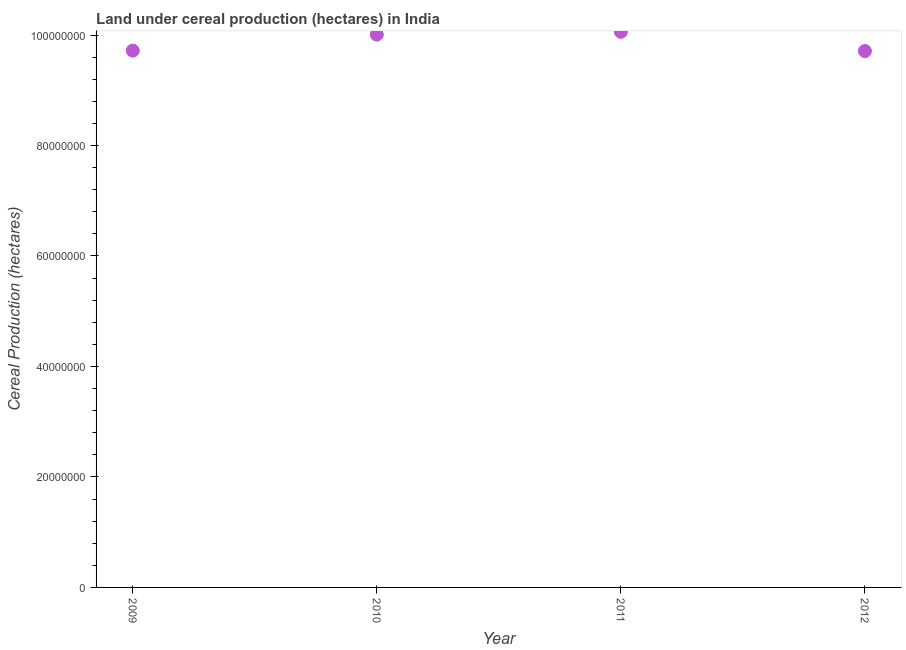What is the land under cereal production in 2011?
Provide a short and direct response. 1.01e+08. Across all years, what is the maximum land under cereal production?
Offer a terse response. 1.01e+08. Across all years, what is the minimum land under cereal production?
Offer a very short reply. 9.71e+07. What is the sum of the land under cereal production?
Offer a terse response. 3.95e+08. What is the difference between the land under cereal production in 2011 and 2012?
Give a very brief answer. 3.49e+06. What is the average land under cereal production per year?
Ensure brevity in your answer.  9.87e+07. What is the median land under cereal production?
Provide a short and direct response. 9.86e+07. Do a majority of the years between 2009 and 2011 (inclusive) have land under cereal production greater than 76000000 hectares?
Make the answer very short. Yes. What is the ratio of the land under cereal production in 2009 to that in 2012?
Ensure brevity in your answer.  1. Is the land under cereal production in 2009 less than that in 2011?
Give a very brief answer. Yes. Is the difference between the land under cereal production in 2010 and 2012 greater than the difference between any two years?
Offer a terse response. No. What is the difference between the highest and the second highest land under cereal production?
Offer a very short reply. 5.10e+05. Is the sum of the land under cereal production in 2009 and 2011 greater than the maximum land under cereal production across all years?
Offer a very short reply. Yes. What is the difference between the highest and the lowest land under cereal production?
Make the answer very short. 3.49e+06. In how many years, is the land under cereal production greater than the average land under cereal production taken over all years?
Provide a succinct answer. 2. How many dotlines are there?
Keep it short and to the point. 1. Are the values on the major ticks of Y-axis written in scientific E-notation?
Make the answer very short. No. Does the graph contain grids?
Keep it short and to the point. No. What is the title of the graph?
Your answer should be compact. Land under cereal production (hectares) in India. What is the label or title of the Y-axis?
Offer a very short reply. Cereal Production (hectares). What is the Cereal Production (hectares) in 2009?
Your response must be concise. 9.72e+07. What is the Cereal Production (hectares) in 2010?
Make the answer very short. 1.00e+08. What is the Cereal Production (hectares) in 2011?
Make the answer very short. 1.01e+08. What is the Cereal Production (hectares) in 2012?
Keep it short and to the point. 9.71e+07. What is the difference between the Cereal Production (hectares) in 2009 and 2010?
Keep it short and to the point. -2.90e+06. What is the difference between the Cereal Production (hectares) in 2009 and 2011?
Offer a very short reply. -3.41e+06. What is the difference between the Cereal Production (hectares) in 2009 and 2012?
Your response must be concise. 7.16e+04. What is the difference between the Cereal Production (hectares) in 2010 and 2011?
Your answer should be very brief. -5.10e+05. What is the difference between the Cereal Production (hectares) in 2010 and 2012?
Provide a succinct answer. 2.98e+06. What is the difference between the Cereal Production (hectares) in 2011 and 2012?
Your answer should be compact. 3.49e+06. What is the ratio of the Cereal Production (hectares) in 2009 to that in 2011?
Keep it short and to the point. 0.97. What is the ratio of the Cereal Production (hectares) in 2009 to that in 2012?
Your answer should be very brief. 1. What is the ratio of the Cereal Production (hectares) in 2010 to that in 2012?
Your response must be concise. 1.03. What is the ratio of the Cereal Production (hectares) in 2011 to that in 2012?
Provide a succinct answer. 1.04. 